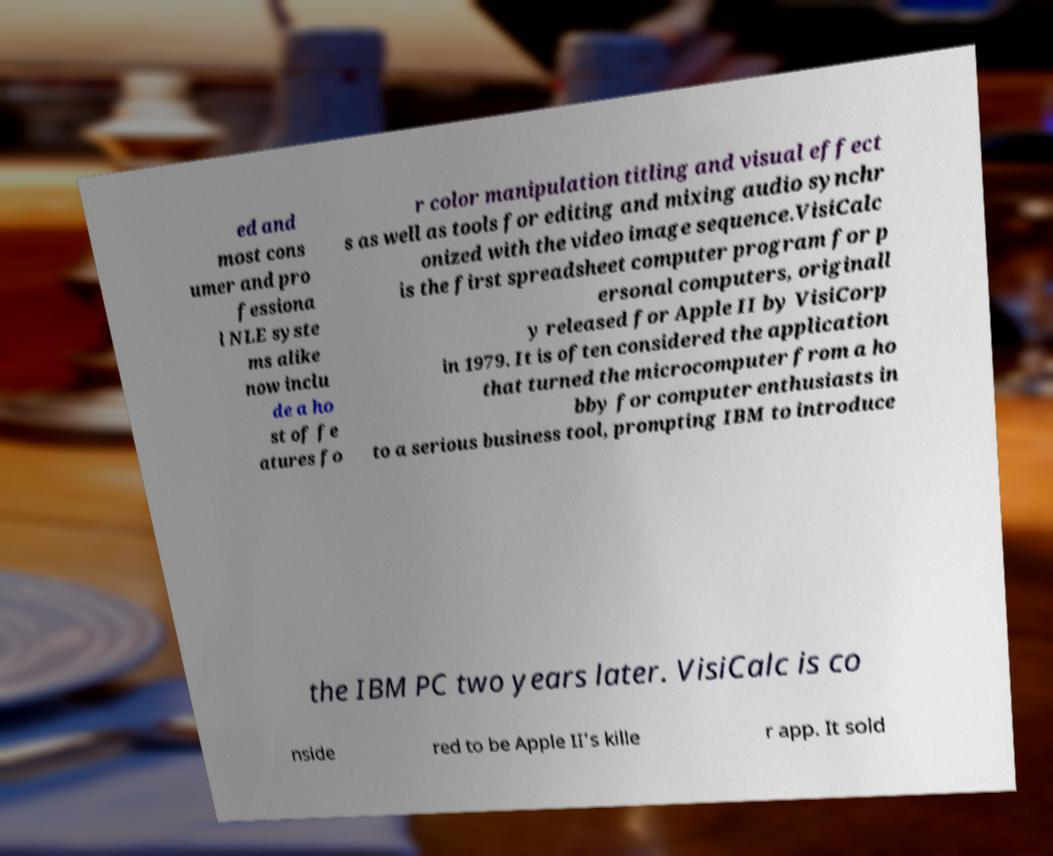Could you assist in decoding the text presented in this image and type it out clearly? ed and most cons umer and pro fessiona l NLE syste ms alike now inclu de a ho st of fe atures fo r color manipulation titling and visual effect s as well as tools for editing and mixing audio synchr onized with the video image sequence.VisiCalc is the first spreadsheet computer program for p ersonal computers, originall y released for Apple II by VisiCorp in 1979. It is often considered the application that turned the microcomputer from a ho bby for computer enthusiasts in to a serious business tool, prompting IBM to introduce the IBM PC two years later. VisiCalc is co nside red to be Apple II's kille r app. It sold 